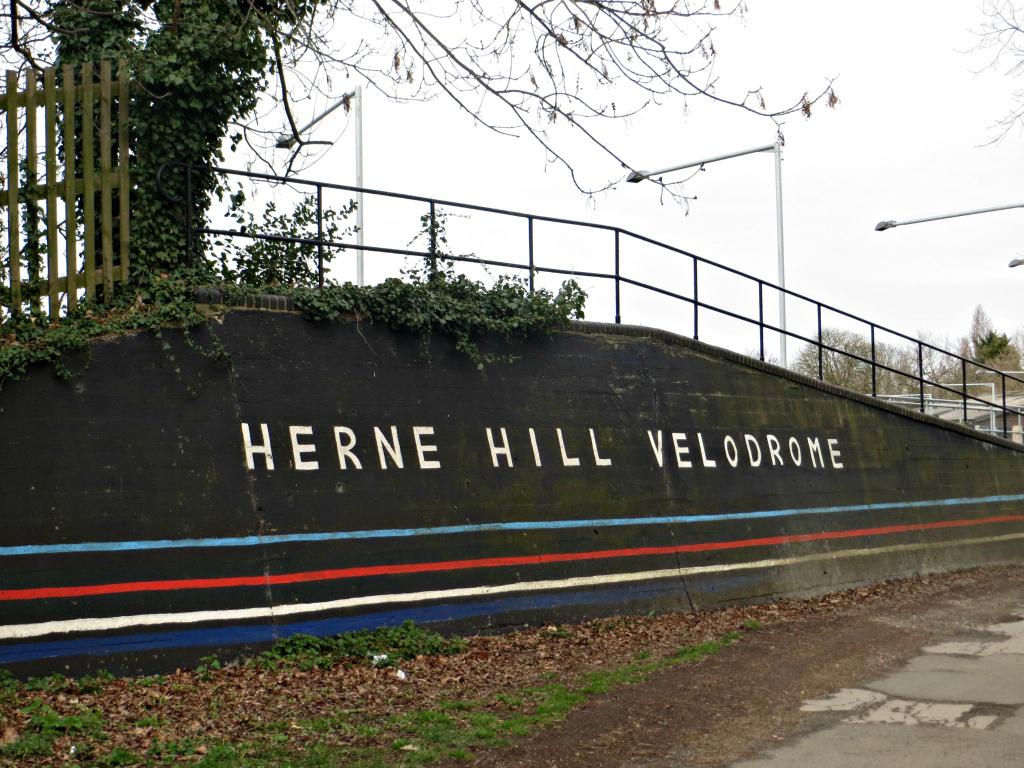What hill is this?
Keep it short and to the point. Herne hill. What is the name of this place?
Give a very brief answer. Herne hill velodrome. 